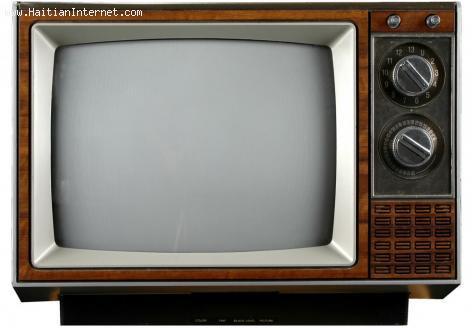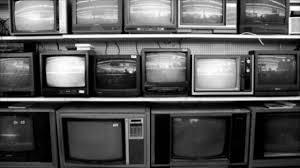The first image is the image on the left, the second image is the image on the right. Analyze the images presented: Is the assertion "Each image contains a single old-fashioned TV in the foreground, and in one image the TV has a picture on the screen." valid? Answer yes or no. No. The first image is the image on the left, the second image is the image on the right. Assess this claim about the two images: "One of the two televisions is showing an image.". Correct or not? Answer yes or no. No. 